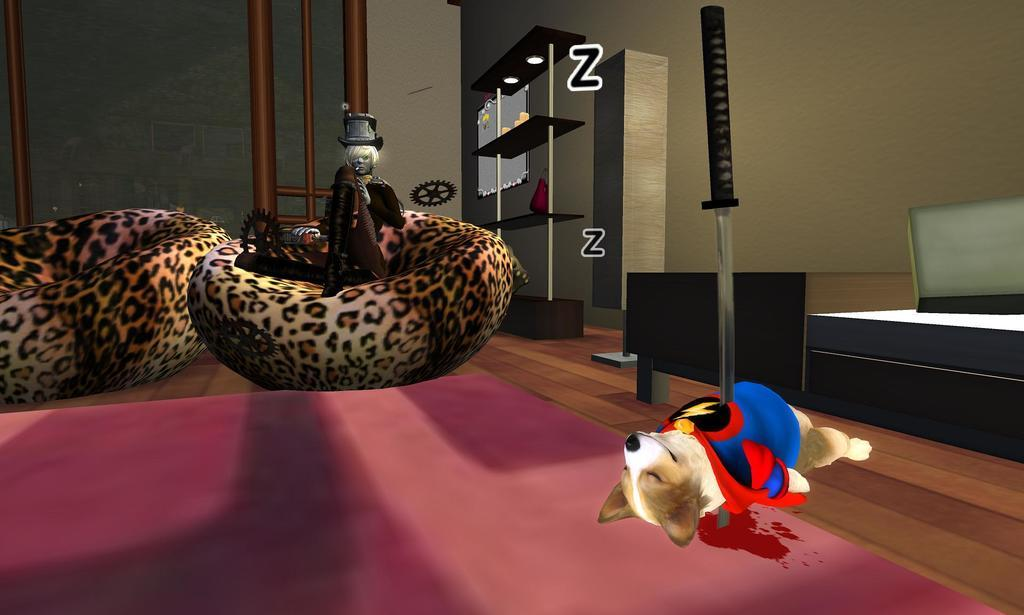What can be seen in the racks in the image? There are objects in the racks in the image. What type of illumination is present in the image? There are lights visible in the image. What type of text can be seen in the image? There are letters in the image. What is visible beneath the objects and lights? The floor is visible in the image. What type of living creature is present in the image? There is an animal in the image. What substance is present in the image that indicates potential violence? There is blood in the image. What object might be used as a weapon in the image? There is a knife in the image. What type of line can be seen in the image? There is no line present in the image. What type of pen is used to write the letters in the image? There is no pen visible in the image, and the method of creating the letters is not specified. 